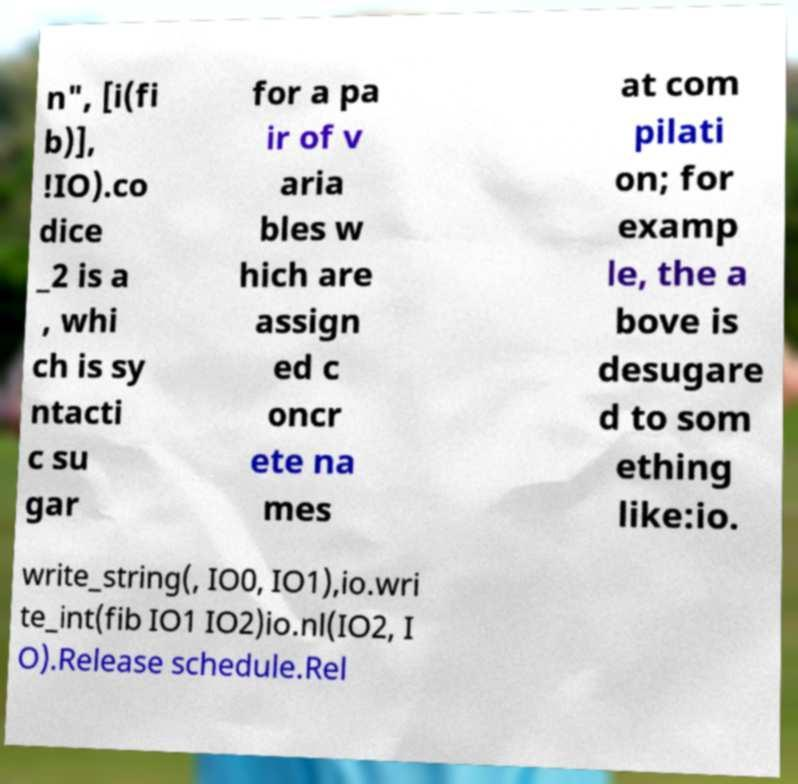Could you extract and type out the text from this image? n", [i(fi b)], !IO).co dice _2 is a , whi ch is sy ntacti c su gar for a pa ir of v aria bles w hich are assign ed c oncr ete na mes at com pilati on; for examp le, the a bove is desugare d to som ething like:io. write_string(, IO0, IO1),io.wri te_int(fib IO1 IO2)io.nl(IO2, I O).Release schedule.Rel 